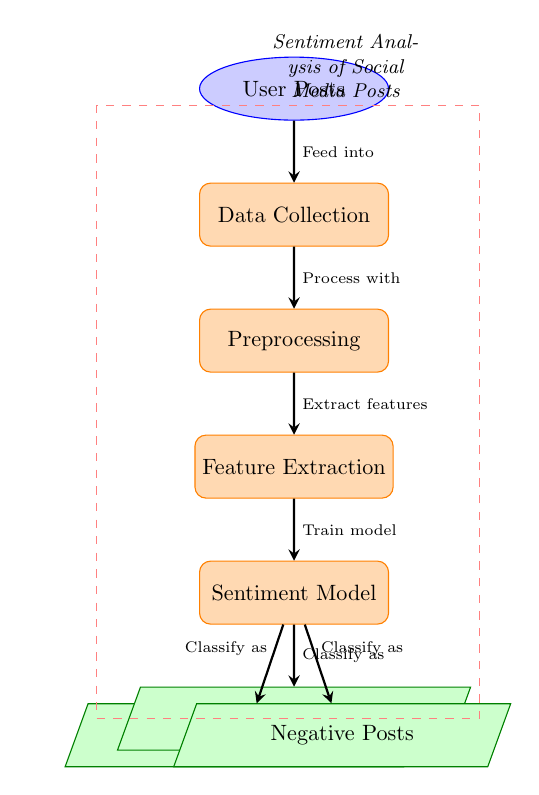What is the first node in the diagram? The first node in the diagram represents the initial input to the process, which is labeled "User Posts".
Answer: User Posts How many outputs are there in the diagram? The diagram presents three outputs labeled as Positive Posts, Neutral Posts, and Negative Posts, indicating the classification results of the sentiment analysis.
Answer: 3 What process follows data collection? After Data Collection, the next process in the diagram is Preprocessing, which is essential for preparing the data for feature extraction.
Answer: Preprocessing What does the Sentiment Model output classify posts as? The Sentiment Model classifies the user posts into three categories: Positive, Neutral, and Negative, based on the sentiment expressed in those posts.
Answer: Positive, Neutral, Negative Which node is immediately before the Sentiment Model? The directly preceding node to the Sentiment Model is the Feature Extraction process, which occurs after Preprocessing and is crucial for identifying relevant characteristics of the posts.
Answer: Feature Extraction What arrow indicates the classification into Positive Posts? The arrow that indicates the classification into Positive Posts points from the Sentiment Model to the Positive Posts output, demonstrating the flow of classified data.
Answer: Classify as How do the Neutral Posts relate to the Sentiment Model? Neutral Posts are an output of the Sentiment Model, representing one of the possible classifications based on the analysis of the user posts' sentiment.
Answer: Output What two processes come before Feature Extraction? The two processes that precede Feature Extraction in the flow are Data Collection and Preprocessing, which are necessary steps for preparing the data for analysis.
Answer: Data Collection, Preprocessing What type of diagram is this considered? This diagram is classified as a Machine Learning Diagram as it illustrates the steps involved in the sentiment analysis process applied to social media posts.
Answer: Machine Learning Diagram 